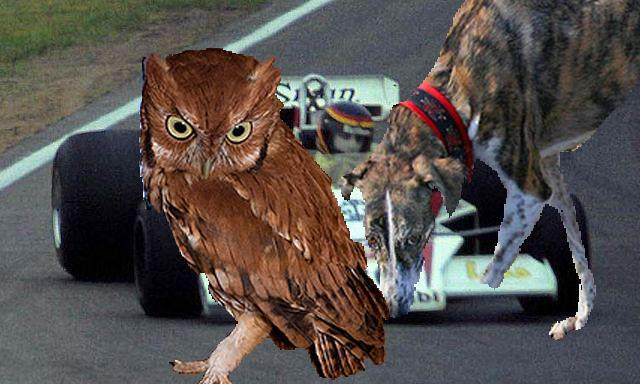Can you tell me what animals are depicted in this image? Certainly! The image intriguingly shows an owl and a cat, each animal presenting a striking and somewhat comical contrast with the background that features a racing car.  What might be the meaning or theme behind this unusual composition? This surreal montage seems to play with themes of speed and natural instincts. The owl, known for its silent flight and keen hunting skills, and the cat, with its agile and stealthy movements, are juxtaposed against a symbol of human-engineered speed—the racing car. It’s an artistic representation that might suggest a commentary on the intersection of nature and technology. 